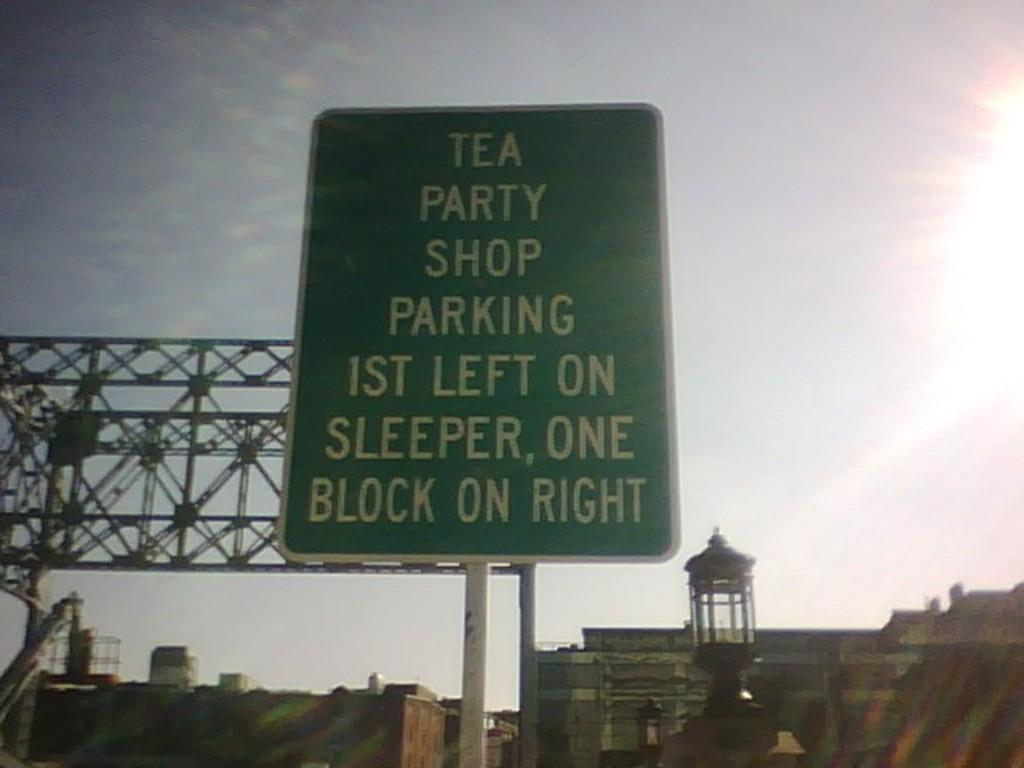<image>
Write a terse but informative summary of the picture. A sign advertises tea party shop parking above the road. 